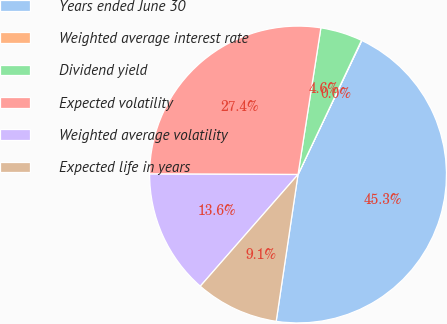Convert chart. <chart><loc_0><loc_0><loc_500><loc_500><pie_chart><fcel>Years ended June 30<fcel>Weighted average interest rate<fcel>Dividend yield<fcel>Expected volatility<fcel>Weighted average volatility<fcel>Expected life in years<nl><fcel>45.28%<fcel>0.04%<fcel>4.57%<fcel>27.41%<fcel>13.61%<fcel>9.09%<nl></chart> 